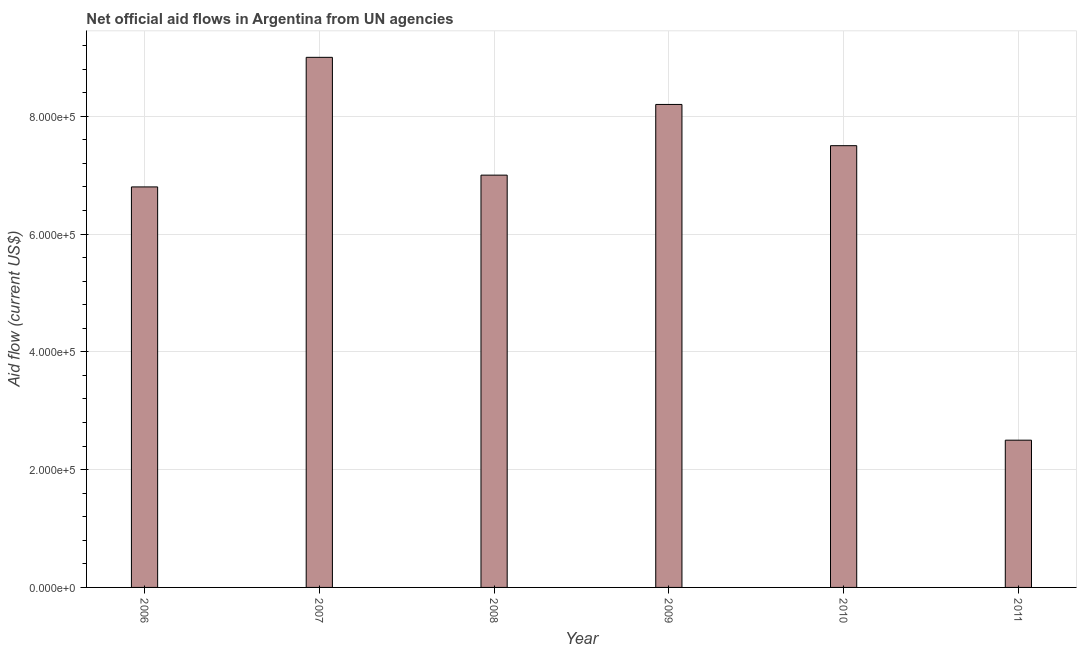Does the graph contain any zero values?
Your answer should be compact. No. What is the title of the graph?
Offer a terse response. Net official aid flows in Argentina from UN agencies. What is the label or title of the X-axis?
Provide a short and direct response. Year. What is the net official flows from un agencies in 2006?
Keep it short and to the point. 6.80e+05. In which year was the net official flows from un agencies minimum?
Your answer should be compact. 2011. What is the sum of the net official flows from un agencies?
Make the answer very short. 4.10e+06. What is the difference between the net official flows from un agencies in 2007 and 2011?
Your response must be concise. 6.50e+05. What is the average net official flows from un agencies per year?
Your answer should be very brief. 6.83e+05. What is the median net official flows from un agencies?
Offer a terse response. 7.25e+05. In how many years, is the net official flows from un agencies greater than 80000 US$?
Your answer should be compact. 6. Do a majority of the years between 2011 and 2006 (inclusive) have net official flows from un agencies greater than 880000 US$?
Provide a succinct answer. Yes. What is the ratio of the net official flows from un agencies in 2008 to that in 2011?
Your response must be concise. 2.8. Is the net official flows from un agencies in 2009 less than that in 2011?
Provide a succinct answer. No. What is the difference between the highest and the second highest net official flows from un agencies?
Keep it short and to the point. 8.00e+04. What is the difference between the highest and the lowest net official flows from un agencies?
Your response must be concise. 6.50e+05. How many bars are there?
Offer a terse response. 6. What is the difference between two consecutive major ticks on the Y-axis?
Provide a short and direct response. 2.00e+05. What is the Aid flow (current US$) in 2006?
Offer a very short reply. 6.80e+05. What is the Aid flow (current US$) of 2007?
Offer a terse response. 9.00e+05. What is the Aid flow (current US$) in 2008?
Give a very brief answer. 7.00e+05. What is the Aid flow (current US$) of 2009?
Provide a succinct answer. 8.20e+05. What is the Aid flow (current US$) in 2010?
Offer a very short reply. 7.50e+05. What is the Aid flow (current US$) in 2011?
Offer a very short reply. 2.50e+05. What is the difference between the Aid flow (current US$) in 2006 and 2007?
Keep it short and to the point. -2.20e+05. What is the difference between the Aid flow (current US$) in 2006 and 2008?
Provide a succinct answer. -2.00e+04. What is the difference between the Aid flow (current US$) in 2006 and 2010?
Offer a very short reply. -7.00e+04. What is the difference between the Aid flow (current US$) in 2007 and 2009?
Ensure brevity in your answer.  8.00e+04. What is the difference between the Aid flow (current US$) in 2007 and 2011?
Ensure brevity in your answer.  6.50e+05. What is the difference between the Aid flow (current US$) in 2008 and 2009?
Give a very brief answer. -1.20e+05. What is the difference between the Aid flow (current US$) in 2008 and 2010?
Make the answer very short. -5.00e+04. What is the difference between the Aid flow (current US$) in 2009 and 2010?
Your answer should be very brief. 7.00e+04. What is the difference between the Aid flow (current US$) in 2009 and 2011?
Keep it short and to the point. 5.70e+05. What is the ratio of the Aid flow (current US$) in 2006 to that in 2007?
Your response must be concise. 0.76. What is the ratio of the Aid flow (current US$) in 2006 to that in 2009?
Provide a short and direct response. 0.83. What is the ratio of the Aid flow (current US$) in 2006 to that in 2010?
Offer a terse response. 0.91. What is the ratio of the Aid flow (current US$) in 2006 to that in 2011?
Your response must be concise. 2.72. What is the ratio of the Aid flow (current US$) in 2007 to that in 2008?
Provide a succinct answer. 1.29. What is the ratio of the Aid flow (current US$) in 2007 to that in 2009?
Keep it short and to the point. 1.1. What is the ratio of the Aid flow (current US$) in 2008 to that in 2009?
Ensure brevity in your answer.  0.85. What is the ratio of the Aid flow (current US$) in 2008 to that in 2010?
Ensure brevity in your answer.  0.93. What is the ratio of the Aid flow (current US$) in 2009 to that in 2010?
Provide a succinct answer. 1.09. What is the ratio of the Aid flow (current US$) in 2009 to that in 2011?
Offer a very short reply. 3.28. What is the ratio of the Aid flow (current US$) in 2010 to that in 2011?
Offer a very short reply. 3. 